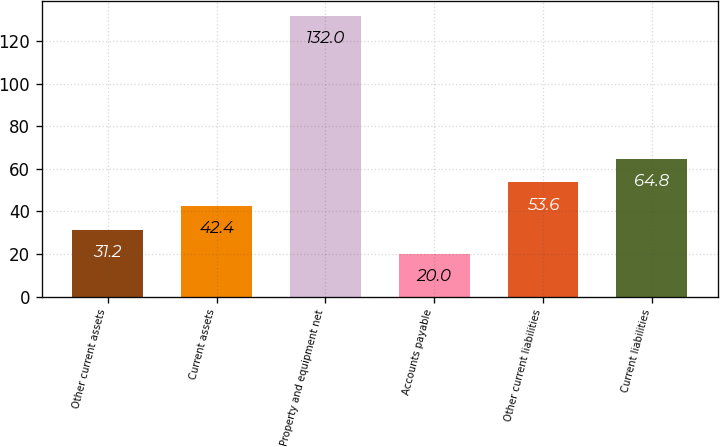<chart> <loc_0><loc_0><loc_500><loc_500><bar_chart><fcel>Other current assets<fcel>Current assets<fcel>Property and equipment net<fcel>Accounts payable<fcel>Other current liabilities<fcel>Current liabilities<nl><fcel>31.2<fcel>42.4<fcel>132<fcel>20<fcel>53.6<fcel>64.8<nl></chart> 